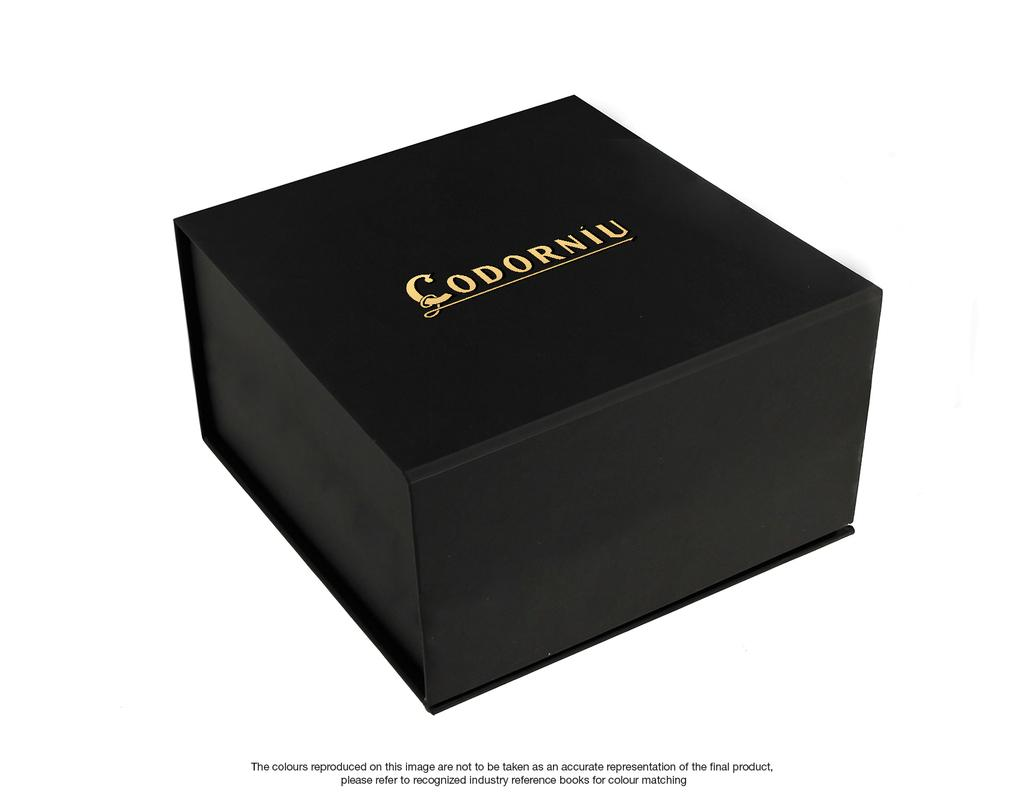<image>
Give a short and clear explanation of the subsequent image. A small black box with the word written on the top is Codorniu 